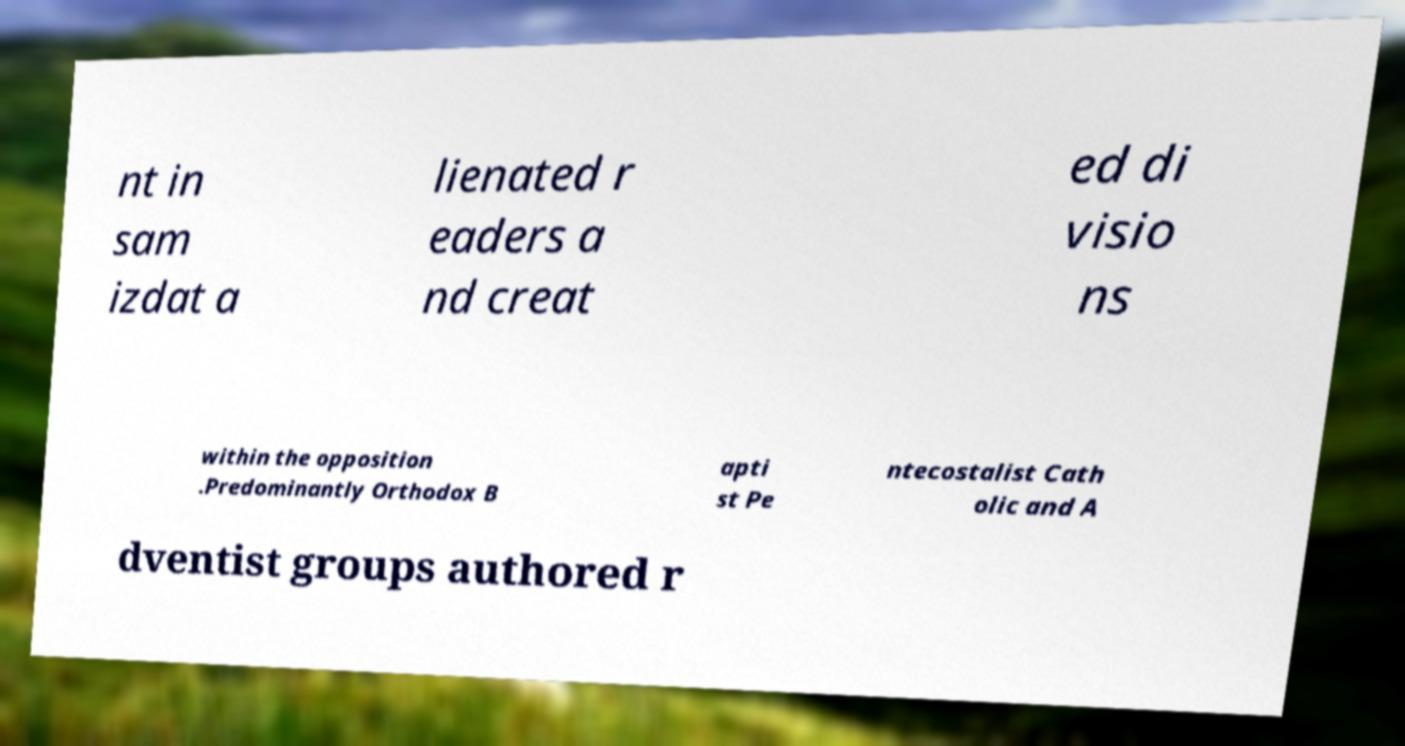What messages or text are displayed in this image? I need them in a readable, typed format. nt in sam izdat a lienated r eaders a nd creat ed di visio ns within the opposition .Predominantly Orthodox B apti st Pe ntecostalist Cath olic and A dventist groups authored r 